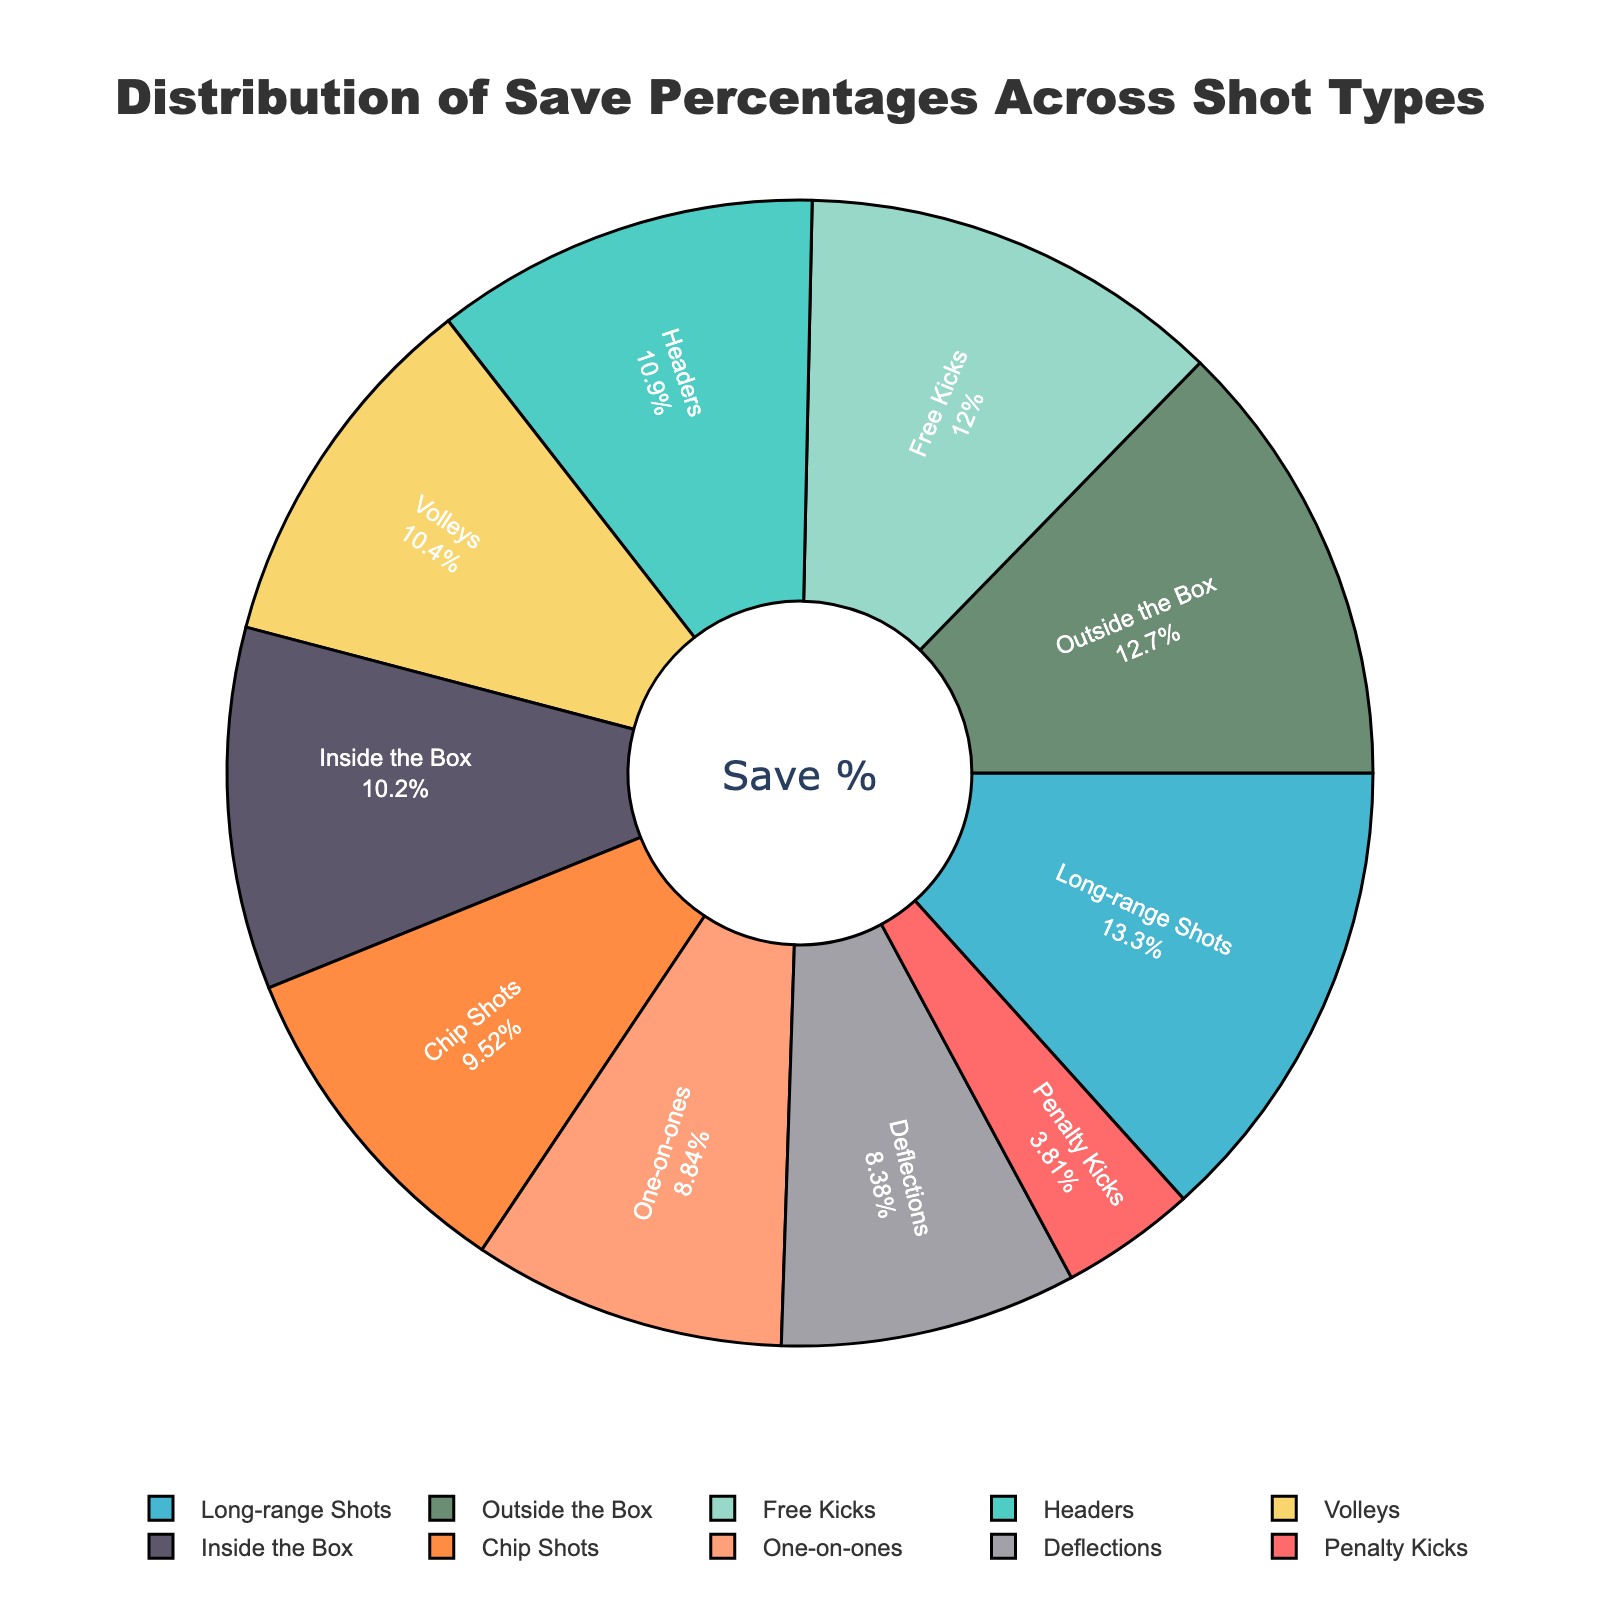Which shot type has the lowest save percentage? Look at the pie chart and find the segment labeled "Penalty Kicks". The percentage next to it shows 25.3%, which is the lowest save percentage among all shot types.
Answer: Penalty Kicks What is the average save percentage for all shot types? Add up all save percentages: 25.3 + 72.1 + 88.5 + 58.7 + 79.4 + 68.9 + 63.2 + 55.6 + 67.8 + 84.3 = 663.8. Divide this by the number of shot types, which is 10. The average is 663.8 / 10 = 66.38.
Answer: 66.38% How much higher is the save percentage for Long-range Shots compared to Penalty Kicks? Locate both segments on the pie chart. Long-range Shots have a save percentage of 88.5, and Penalty Kicks have 25.3. Subtract 25.3 from 88.5 to find the difference: 88.5 - 25.3 = 63.2.
Answer: 63.2% Which two shot types have save percentages closest to each other? Compare the save percentages listed. The closest save percentages are for Volleys (68.9) and Inside the Box (67.8), with a difference of just 1.1 (68.9 - 67.8 = 1.1).
Answer: Volleys and Inside the Box What percentage of the total save percentages is made up by Headers and Free Kicks combined? Add the save percentages for Headers (72.1) and Free Kicks (79.4). The total is 72.1 + 79.4 = 151.5. Calculate the percentage of the total save percentages (663.8) this represents: (151.5 / 663.8) * 100 ≈ 22.82%.
Answer: 22.82% Which shot type has a save percentage just above 50% but below 60%? Look at the pie chart and identify any segments with values between 50% and 60%. One-on-ones have a save percentage of 58.7%, which fits this range.
Answer: One-on-ones Is the save percentage for Chip Shots closer to Long-range Shots or Deflections? Calculate the differences: Chip Shots (63.2) to Long-range Shots (88.5) is 88.5 - 63.2 = 25.3, and Chip Shots to Deflections (55.6) is 63.2 - 55.6 = 7.6. Chip Shots are closer to Deflections.
Answer: Deflections What is the difference in save percentages between the highest and second-highest shot types? The highest save percentage is Long-range Shots (88.5), and the second-highest is Outside the Box (84.3). The difference is 88.5 - 84.3 = 4.2.
Answer: 4.2% Which shot type has the largest visual segment in the pie chart? The largest visual segment corresponds to the highest percentage, which in this case is Long-range Shots with 88.5%.
Answer: Long-range Shots 